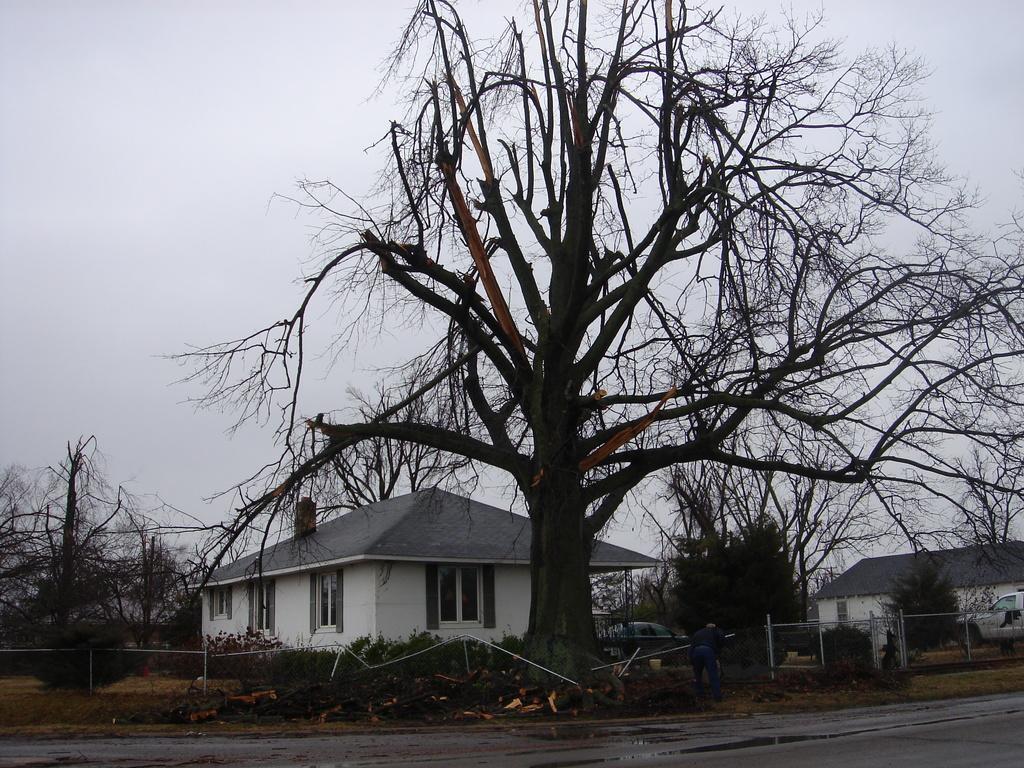Can you describe this image briefly? In this picture there are buildings and trees and there is a person standing and holding the object and there are vehicles. At the top there is sky. At the bottom there is a road. 